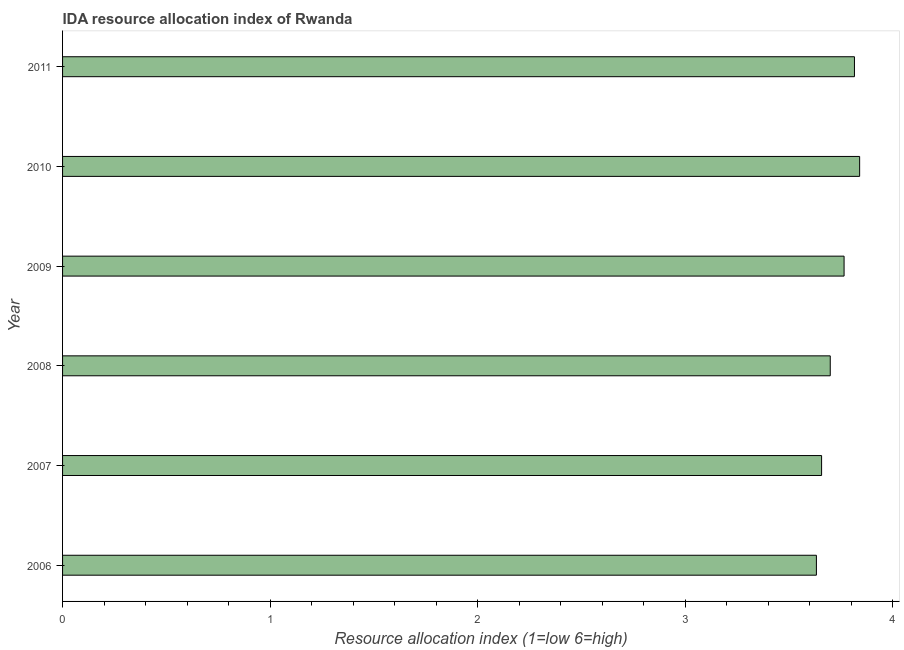What is the title of the graph?
Your answer should be very brief. IDA resource allocation index of Rwanda. What is the label or title of the X-axis?
Your answer should be compact. Resource allocation index (1=low 6=high). What is the ida resource allocation index in 2006?
Make the answer very short. 3.63. Across all years, what is the maximum ida resource allocation index?
Offer a terse response. 3.84. Across all years, what is the minimum ida resource allocation index?
Keep it short and to the point. 3.63. In which year was the ida resource allocation index maximum?
Ensure brevity in your answer.  2010. What is the sum of the ida resource allocation index?
Give a very brief answer. 22.42. What is the difference between the ida resource allocation index in 2008 and 2010?
Your answer should be compact. -0.14. What is the average ida resource allocation index per year?
Provide a short and direct response. 3.74. What is the median ida resource allocation index?
Offer a very short reply. 3.73. Is the difference between the ida resource allocation index in 2008 and 2009 greater than the difference between any two years?
Offer a very short reply. No. What is the difference between the highest and the second highest ida resource allocation index?
Offer a very short reply. 0.03. What is the difference between the highest and the lowest ida resource allocation index?
Provide a short and direct response. 0.21. How many bars are there?
Provide a succinct answer. 6. How many years are there in the graph?
Ensure brevity in your answer.  6. Are the values on the major ticks of X-axis written in scientific E-notation?
Keep it short and to the point. No. What is the Resource allocation index (1=low 6=high) in 2006?
Make the answer very short. 3.63. What is the Resource allocation index (1=low 6=high) in 2007?
Your response must be concise. 3.66. What is the Resource allocation index (1=low 6=high) in 2009?
Ensure brevity in your answer.  3.77. What is the Resource allocation index (1=low 6=high) of 2010?
Make the answer very short. 3.84. What is the Resource allocation index (1=low 6=high) in 2011?
Offer a terse response. 3.82. What is the difference between the Resource allocation index (1=low 6=high) in 2006 and 2007?
Keep it short and to the point. -0.03. What is the difference between the Resource allocation index (1=low 6=high) in 2006 and 2008?
Your response must be concise. -0.07. What is the difference between the Resource allocation index (1=low 6=high) in 2006 and 2009?
Give a very brief answer. -0.13. What is the difference between the Resource allocation index (1=low 6=high) in 2006 and 2010?
Make the answer very short. -0.21. What is the difference between the Resource allocation index (1=low 6=high) in 2006 and 2011?
Ensure brevity in your answer.  -0.18. What is the difference between the Resource allocation index (1=low 6=high) in 2007 and 2008?
Make the answer very short. -0.04. What is the difference between the Resource allocation index (1=low 6=high) in 2007 and 2009?
Offer a terse response. -0.11. What is the difference between the Resource allocation index (1=low 6=high) in 2007 and 2010?
Your answer should be compact. -0.18. What is the difference between the Resource allocation index (1=low 6=high) in 2007 and 2011?
Ensure brevity in your answer.  -0.16. What is the difference between the Resource allocation index (1=low 6=high) in 2008 and 2009?
Keep it short and to the point. -0.07. What is the difference between the Resource allocation index (1=low 6=high) in 2008 and 2010?
Offer a very short reply. -0.14. What is the difference between the Resource allocation index (1=low 6=high) in 2008 and 2011?
Your answer should be compact. -0.12. What is the difference between the Resource allocation index (1=low 6=high) in 2009 and 2010?
Give a very brief answer. -0.07. What is the difference between the Resource allocation index (1=low 6=high) in 2009 and 2011?
Keep it short and to the point. -0.05. What is the difference between the Resource allocation index (1=low 6=high) in 2010 and 2011?
Give a very brief answer. 0.03. What is the ratio of the Resource allocation index (1=low 6=high) in 2006 to that in 2009?
Offer a very short reply. 0.96. What is the ratio of the Resource allocation index (1=low 6=high) in 2006 to that in 2010?
Give a very brief answer. 0.95. What is the ratio of the Resource allocation index (1=low 6=high) in 2007 to that in 2009?
Your answer should be very brief. 0.97. What is the ratio of the Resource allocation index (1=low 6=high) in 2008 to that in 2010?
Provide a short and direct response. 0.96. What is the ratio of the Resource allocation index (1=low 6=high) in 2009 to that in 2010?
Provide a succinct answer. 0.98. What is the ratio of the Resource allocation index (1=low 6=high) in 2009 to that in 2011?
Keep it short and to the point. 0.99. 